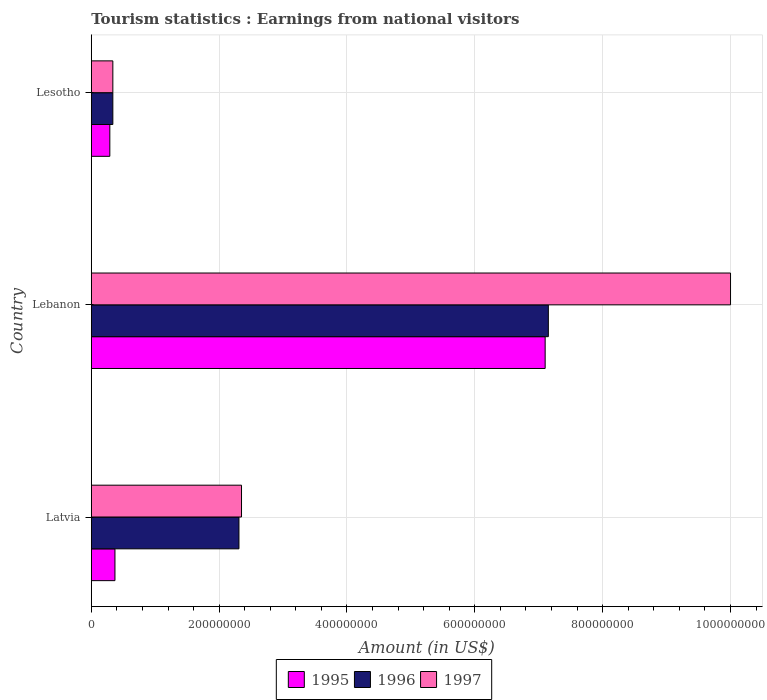Are the number of bars on each tick of the Y-axis equal?
Provide a short and direct response. Yes. How many bars are there on the 1st tick from the top?
Give a very brief answer. 3. What is the label of the 1st group of bars from the top?
Your response must be concise. Lesotho. What is the earnings from national visitors in 1995 in Latvia?
Make the answer very short. 3.70e+07. Across all countries, what is the minimum earnings from national visitors in 1995?
Your response must be concise. 2.90e+07. In which country was the earnings from national visitors in 1997 maximum?
Offer a terse response. Lebanon. In which country was the earnings from national visitors in 1997 minimum?
Your answer should be very brief. Lesotho. What is the total earnings from national visitors in 1995 in the graph?
Give a very brief answer. 7.76e+08. What is the difference between the earnings from national visitors in 1997 in Lebanon and that in Lesotho?
Offer a terse response. 9.66e+08. What is the difference between the earnings from national visitors in 1997 in Lesotho and the earnings from national visitors in 1995 in Latvia?
Provide a short and direct response. -3.30e+06. What is the average earnings from national visitors in 1997 per country?
Offer a very short reply. 4.23e+08. What is the difference between the earnings from national visitors in 1996 and earnings from national visitors in 1995 in Lesotho?
Your answer should be very brief. 4.70e+06. In how many countries, is the earnings from national visitors in 1996 greater than 600000000 US$?
Make the answer very short. 1. What is the ratio of the earnings from national visitors in 1995 in Lebanon to that in Lesotho?
Give a very brief answer. 24.48. Is the difference between the earnings from national visitors in 1996 in Latvia and Lesotho greater than the difference between the earnings from national visitors in 1995 in Latvia and Lesotho?
Your answer should be very brief. Yes. What is the difference between the highest and the second highest earnings from national visitors in 1997?
Your answer should be very brief. 7.65e+08. What is the difference between the highest and the lowest earnings from national visitors in 1997?
Give a very brief answer. 9.66e+08. Is the sum of the earnings from national visitors in 1995 in Latvia and Lebanon greater than the maximum earnings from national visitors in 1996 across all countries?
Provide a short and direct response. Yes. What does the 3rd bar from the bottom in Lesotho represents?
Your answer should be compact. 1997. Is it the case that in every country, the sum of the earnings from national visitors in 1996 and earnings from national visitors in 1997 is greater than the earnings from national visitors in 1995?
Offer a terse response. Yes. How many countries are there in the graph?
Provide a short and direct response. 3. Are the values on the major ticks of X-axis written in scientific E-notation?
Give a very brief answer. No. Does the graph contain any zero values?
Keep it short and to the point. No. Does the graph contain grids?
Provide a short and direct response. Yes. How many legend labels are there?
Your response must be concise. 3. What is the title of the graph?
Your answer should be compact. Tourism statistics : Earnings from national visitors. What is the label or title of the X-axis?
Provide a short and direct response. Amount (in US$). What is the label or title of the Y-axis?
Offer a very short reply. Country. What is the Amount (in US$) in 1995 in Latvia?
Make the answer very short. 3.70e+07. What is the Amount (in US$) of 1996 in Latvia?
Your answer should be compact. 2.31e+08. What is the Amount (in US$) in 1997 in Latvia?
Give a very brief answer. 2.35e+08. What is the Amount (in US$) in 1995 in Lebanon?
Your response must be concise. 7.10e+08. What is the Amount (in US$) of 1996 in Lebanon?
Ensure brevity in your answer.  7.15e+08. What is the Amount (in US$) of 1995 in Lesotho?
Provide a short and direct response. 2.90e+07. What is the Amount (in US$) in 1996 in Lesotho?
Give a very brief answer. 3.37e+07. What is the Amount (in US$) in 1997 in Lesotho?
Ensure brevity in your answer.  3.37e+07. Across all countries, what is the maximum Amount (in US$) in 1995?
Offer a terse response. 7.10e+08. Across all countries, what is the maximum Amount (in US$) of 1996?
Keep it short and to the point. 7.15e+08. Across all countries, what is the maximum Amount (in US$) in 1997?
Your response must be concise. 1.00e+09. Across all countries, what is the minimum Amount (in US$) of 1995?
Provide a short and direct response. 2.90e+07. Across all countries, what is the minimum Amount (in US$) in 1996?
Give a very brief answer. 3.37e+07. Across all countries, what is the minimum Amount (in US$) in 1997?
Offer a terse response. 3.37e+07. What is the total Amount (in US$) in 1995 in the graph?
Offer a terse response. 7.76e+08. What is the total Amount (in US$) in 1996 in the graph?
Give a very brief answer. 9.80e+08. What is the total Amount (in US$) of 1997 in the graph?
Your answer should be very brief. 1.27e+09. What is the difference between the Amount (in US$) of 1995 in Latvia and that in Lebanon?
Offer a terse response. -6.73e+08. What is the difference between the Amount (in US$) of 1996 in Latvia and that in Lebanon?
Make the answer very short. -4.84e+08. What is the difference between the Amount (in US$) in 1997 in Latvia and that in Lebanon?
Your answer should be very brief. -7.65e+08. What is the difference between the Amount (in US$) of 1996 in Latvia and that in Lesotho?
Your answer should be compact. 1.97e+08. What is the difference between the Amount (in US$) in 1997 in Latvia and that in Lesotho?
Your response must be concise. 2.01e+08. What is the difference between the Amount (in US$) of 1995 in Lebanon and that in Lesotho?
Provide a short and direct response. 6.81e+08. What is the difference between the Amount (in US$) of 1996 in Lebanon and that in Lesotho?
Your answer should be very brief. 6.81e+08. What is the difference between the Amount (in US$) of 1997 in Lebanon and that in Lesotho?
Ensure brevity in your answer.  9.66e+08. What is the difference between the Amount (in US$) in 1995 in Latvia and the Amount (in US$) in 1996 in Lebanon?
Keep it short and to the point. -6.78e+08. What is the difference between the Amount (in US$) in 1995 in Latvia and the Amount (in US$) in 1997 in Lebanon?
Your answer should be very brief. -9.63e+08. What is the difference between the Amount (in US$) in 1996 in Latvia and the Amount (in US$) in 1997 in Lebanon?
Your response must be concise. -7.69e+08. What is the difference between the Amount (in US$) of 1995 in Latvia and the Amount (in US$) of 1996 in Lesotho?
Ensure brevity in your answer.  3.30e+06. What is the difference between the Amount (in US$) in 1995 in Latvia and the Amount (in US$) in 1997 in Lesotho?
Offer a very short reply. 3.30e+06. What is the difference between the Amount (in US$) of 1996 in Latvia and the Amount (in US$) of 1997 in Lesotho?
Offer a very short reply. 1.97e+08. What is the difference between the Amount (in US$) of 1995 in Lebanon and the Amount (in US$) of 1996 in Lesotho?
Make the answer very short. 6.76e+08. What is the difference between the Amount (in US$) of 1995 in Lebanon and the Amount (in US$) of 1997 in Lesotho?
Keep it short and to the point. 6.76e+08. What is the difference between the Amount (in US$) of 1996 in Lebanon and the Amount (in US$) of 1997 in Lesotho?
Ensure brevity in your answer.  6.81e+08. What is the average Amount (in US$) of 1995 per country?
Provide a short and direct response. 2.59e+08. What is the average Amount (in US$) in 1996 per country?
Give a very brief answer. 3.27e+08. What is the average Amount (in US$) of 1997 per country?
Keep it short and to the point. 4.23e+08. What is the difference between the Amount (in US$) in 1995 and Amount (in US$) in 1996 in Latvia?
Offer a terse response. -1.94e+08. What is the difference between the Amount (in US$) of 1995 and Amount (in US$) of 1997 in Latvia?
Give a very brief answer. -1.98e+08. What is the difference between the Amount (in US$) in 1995 and Amount (in US$) in 1996 in Lebanon?
Offer a very short reply. -5.00e+06. What is the difference between the Amount (in US$) in 1995 and Amount (in US$) in 1997 in Lebanon?
Offer a very short reply. -2.90e+08. What is the difference between the Amount (in US$) of 1996 and Amount (in US$) of 1997 in Lebanon?
Keep it short and to the point. -2.85e+08. What is the difference between the Amount (in US$) in 1995 and Amount (in US$) in 1996 in Lesotho?
Give a very brief answer. -4.70e+06. What is the difference between the Amount (in US$) of 1995 and Amount (in US$) of 1997 in Lesotho?
Offer a very short reply. -4.70e+06. What is the ratio of the Amount (in US$) of 1995 in Latvia to that in Lebanon?
Your answer should be compact. 0.05. What is the ratio of the Amount (in US$) of 1996 in Latvia to that in Lebanon?
Give a very brief answer. 0.32. What is the ratio of the Amount (in US$) in 1997 in Latvia to that in Lebanon?
Provide a succinct answer. 0.23. What is the ratio of the Amount (in US$) in 1995 in Latvia to that in Lesotho?
Your answer should be very brief. 1.28. What is the ratio of the Amount (in US$) in 1996 in Latvia to that in Lesotho?
Your answer should be very brief. 6.85. What is the ratio of the Amount (in US$) in 1997 in Latvia to that in Lesotho?
Make the answer very short. 6.97. What is the ratio of the Amount (in US$) in 1995 in Lebanon to that in Lesotho?
Your answer should be very brief. 24.48. What is the ratio of the Amount (in US$) in 1996 in Lebanon to that in Lesotho?
Your response must be concise. 21.22. What is the ratio of the Amount (in US$) in 1997 in Lebanon to that in Lesotho?
Provide a short and direct response. 29.67. What is the difference between the highest and the second highest Amount (in US$) of 1995?
Make the answer very short. 6.73e+08. What is the difference between the highest and the second highest Amount (in US$) of 1996?
Your response must be concise. 4.84e+08. What is the difference between the highest and the second highest Amount (in US$) of 1997?
Your response must be concise. 7.65e+08. What is the difference between the highest and the lowest Amount (in US$) in 1995?
Make the answer very short. 6.81e+08. What is the difference between the highest and the lowest Amount (in US$) in 1996?
Your answer should be compact. 6.81e+08. What is the difference between the highest and the lowest Amount (in US$) in 1997?
Make the answer very short. 9.66e+08. 